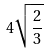<formula> <loc_0><loc_0><loc_500><loc_500>4 \sqrt { \frac { 2 } { 3 } }</formula> 